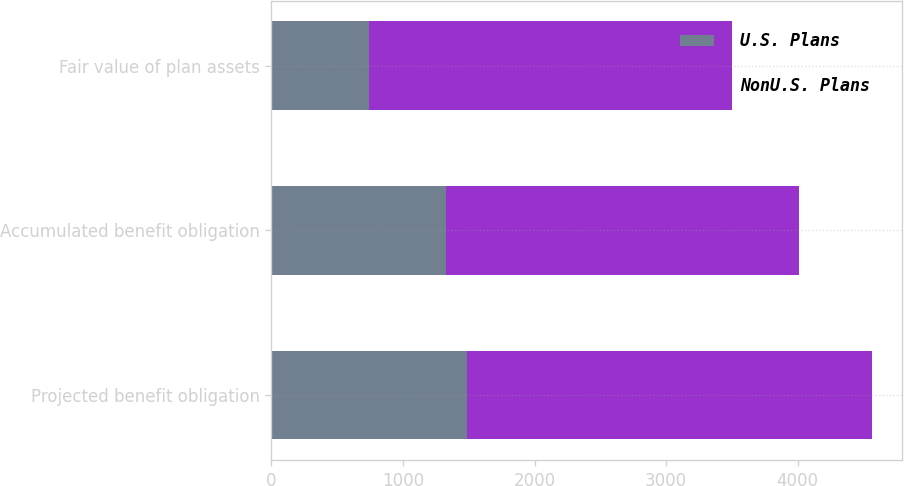Convert chart. <chart><loc_0><loc_0><loc_500><loc_500><stacked_bar_chart><ecel><fcel>Projected benefit obligation<fcel>Accumulated benefit obligation<fcel>Fair value of plan assets<nl><fcel>U.S. Plans<fcel>1486<fcel>1323<fcel>740<nl><fcel>NonU.S. Plans<fcel>3079<fcel>2689<fcel>2760<nl></chart> 